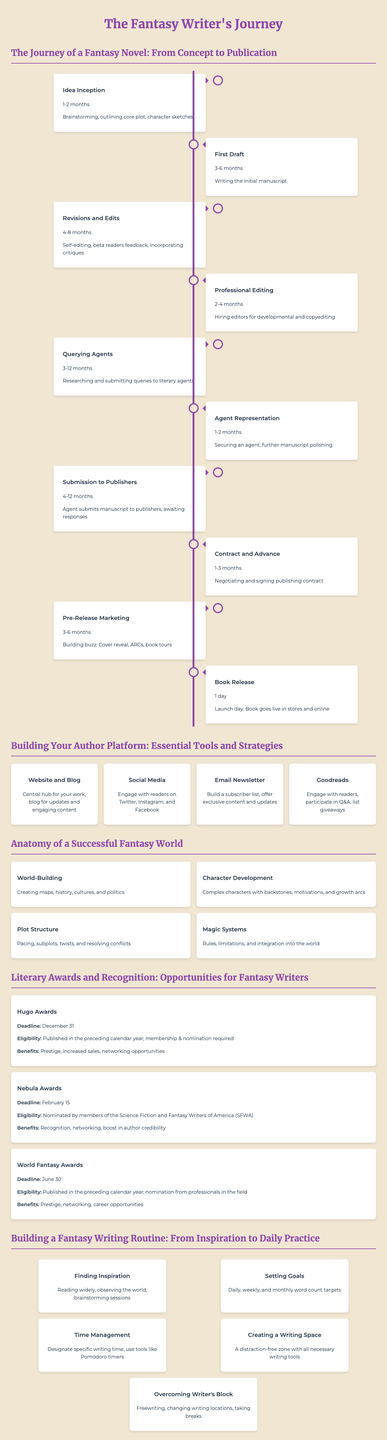What is the average time for revising and editing a fantasy novel? The "Revisions and Edits" step in the timeline states it takes 4-8 months.
Answer: 4-8 months How many steps are there in the journey of a fantasy novel from concept to publication? The timeline presents 9 distinct steps from "Idea Inception" to "Book Release."
Answer: 9 What is one essential tool recommended for building an author platform? The infographic lists tools such as "Website and Blog," "Social Media," and "Email Newsletter."
Answer: Website and Blog What does world-building involve according to the infographic? The "Anatomy of a Successful Fantasy World" section mentions creating maps, history, cultures, and politics.
Answer: Creating maps, history, cultures, and politics When is the deadline for the Hugo Awards? The "Literary Awards and Recognition" section states the deadline is December 31.
Answer: December 31 How long does the querying agents process typically take? The infographic indicates that "Querying Agents" lasts for 3-12 months.
Answer: 3-12 months What is one technique suggested to overcome writer's block? The "Building a Fantasy Writing Routine" section includes "Freewriting" as a technique.
Answer: Freewriting What kind of space should a fantasy writer create? The infographic recommends creating a "distraction-free zone" as part of a writing routine.
Answer: Distraction-free zone What benefit does receiving a Hugo Award provide? The benefits listed include Prestige, increased sales, and networking opportunities.
Answer: Prestige, increased sales, networking opportunities 